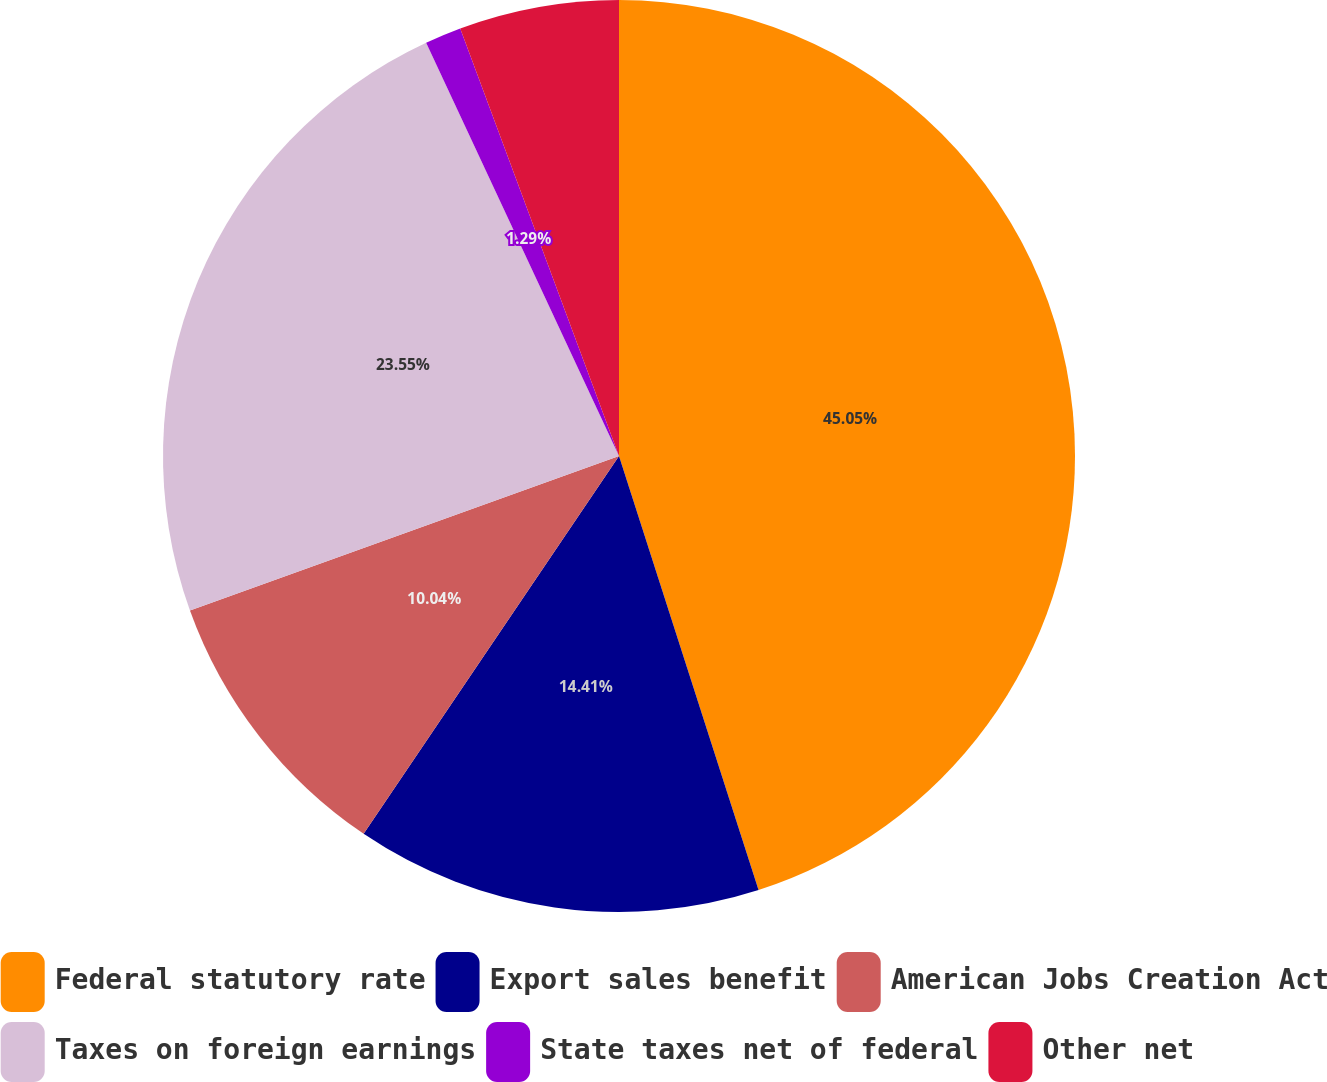Convert chart. <chart><loc_0><loc_0><loc_500><loc_500><pie_chart><fcel>Federal statutory rate<fcel>Export sales benefit<fcel>American Jobs Creation Act<fcel>Taxes on foreign earnings<fcel>State taxes net of federal<fcel>Other net<nl><fcel>45.05%<fcel>14.41%<fcel>10.04%<fcel>23.55%<fcel>1.29%<fcel>5.66%<nl></chart> 